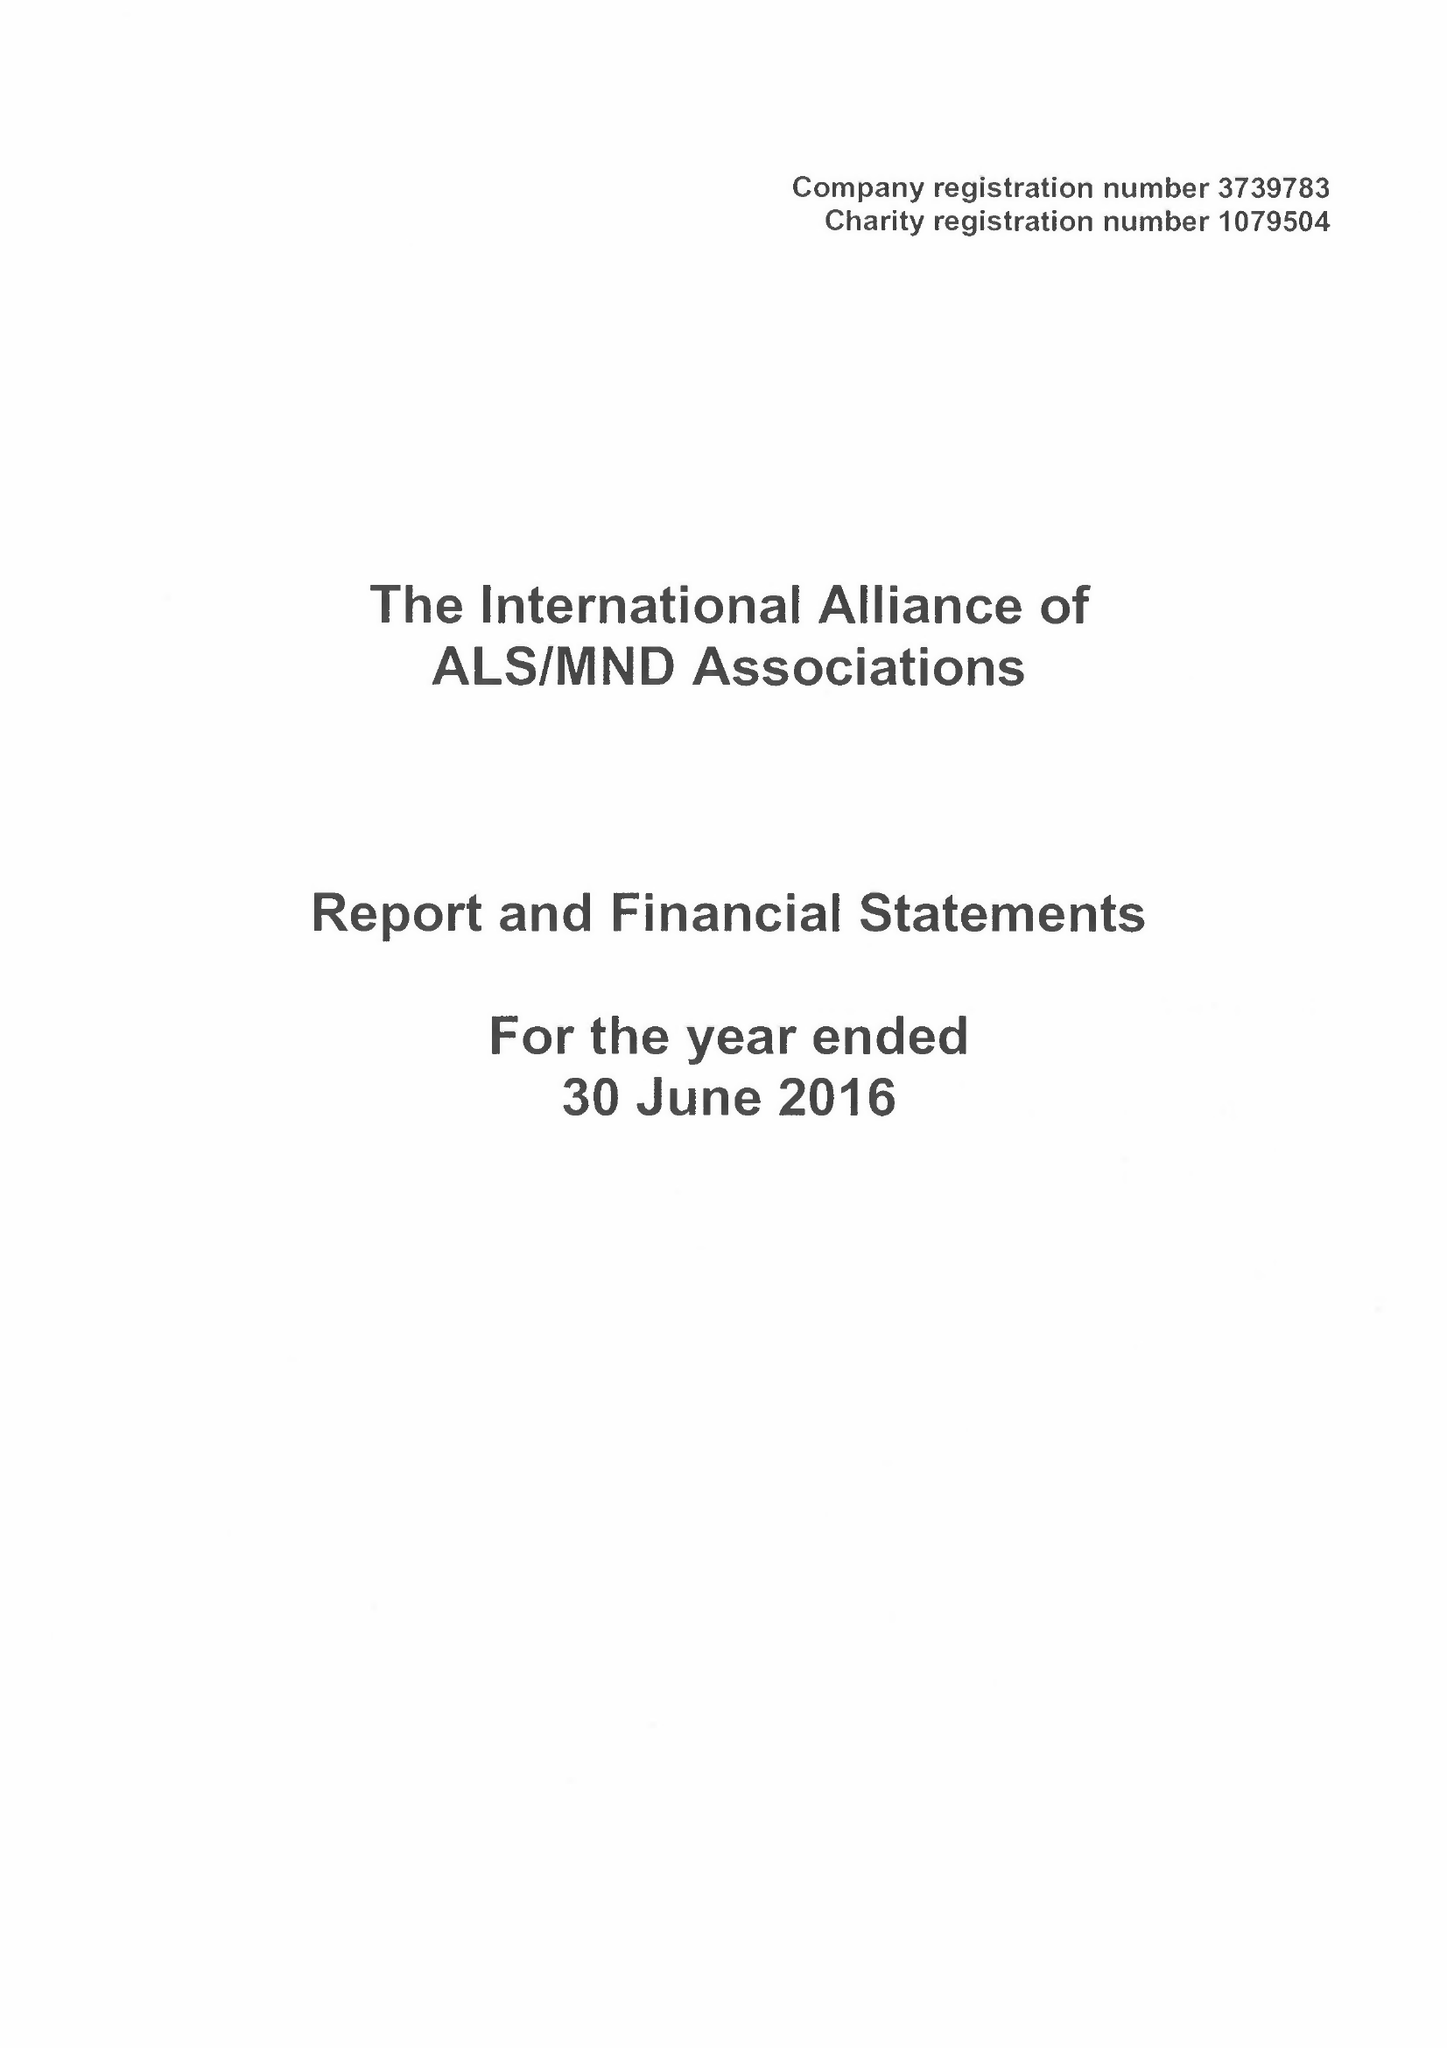What is the value for the income_annually_in_british_pounds?
Answer the question using a single word or phrase. 148391.00 